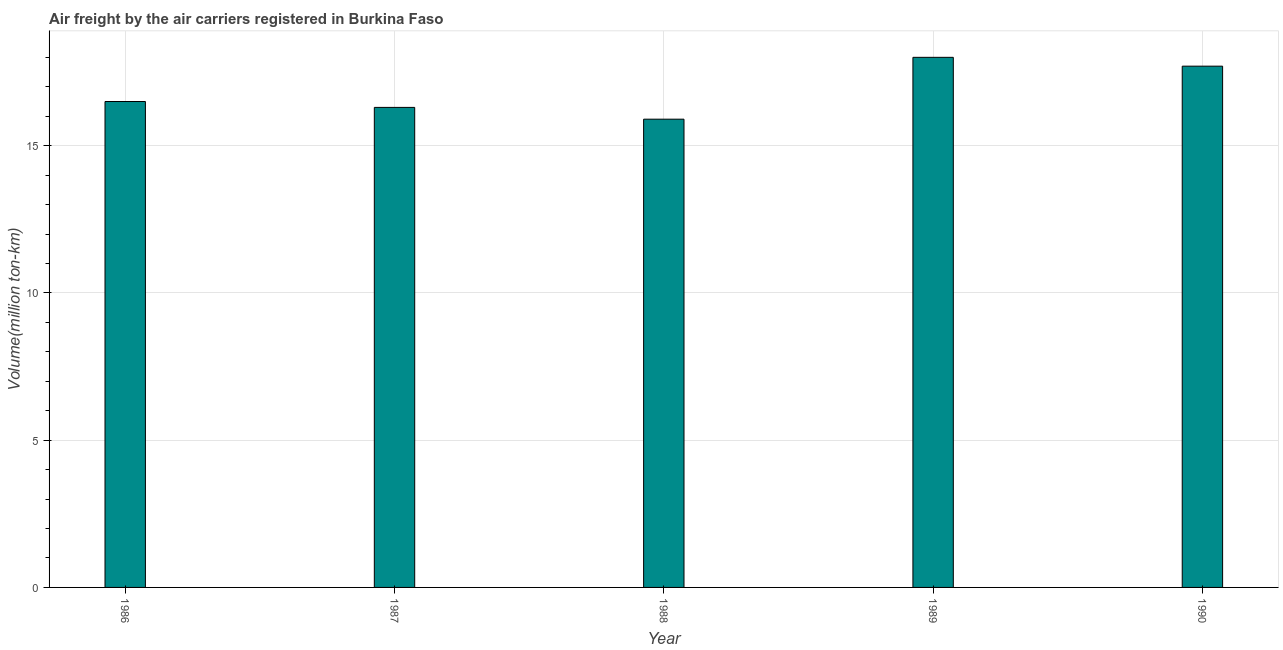Does the graph contain any zero values?
Your response must be concise. No. What is the title of the graph?
Keep it short and to the point. Air freight by the air carriers registered in Burkina Faso. What is the label or title of the Y-axis?
Offer a very short reply. Volume(million ton-km). What is the air freight in 1990?
Your response must be concise. 17.7. Across all years, what is the minimum air freight?
Your response must be concise. 15.9. In which year was the air freight minimum?
Your answer should be very brief. 1988. What is the sum of the air freight?
Provide a succinct answer. 84.4. What is the average air freight per year?
Ensure brevity in your answer.  16.88. Do a majority of the years between 1990 and 1989 (inclusive) have air freight greater than 2 million ton-km?
Your answer should be compact. No. What is the ratio of the air freight in 1987 to that in 1990?
Make the answer very short. 0.92. Is the air freight in 1986 less than that in 1987?
Provide a succinct answer. No. Is the difference between the air freight in 1987 and 1989 greater than the difference between any two years?
Offer a terse response. No. What is the difference between the highest and the second highest air freight?
Offer a very short reply. 0.3. What is the difference between the highest and the lowest air freight?
Provide a succinct answer. 2.1. Are all the bars in the graph horizontal?
Give a very brief answer. No. What is the difference between two consecutive major ticks on the Y-axis?
Your answer should be very brief. 5. Are the values on the major ticks of Y-axis written in scientific E-notation?
Your answer should be very brief. No. What is the Volume(million ton-km) in 1986?
Provide a short and direct response. 16.5. What is the Volume(million ton-km) in 1987?
Make the answer very short. 16.3. What is the Volume(million ton-km) in 1988?
Ensure brevity in your answer.  15.9. What is the Volume(million ton-km) of 1990?
Give a very brief answer. 17.7. What is the difference between the Volume(million ton-km) in 1986 and 1987?
Give a very brief answer. 0.2. What is the difference between the Volume(million ton-km) in 1986 and 1990?
Give a very brief answer. -1.2. What is the difference between the Volume(million ton-km) in 1987 and 1988?
Your answer should be very brief. 0.4. What is the difference between the Volume(million ton-km) in 1987 and 1989?
Provide a short and direct response. -1.7. What is the difference between the Volume(million ton-km) in 1988 and 1989?
Your answer should be very brief. -2.1. What is the ratio of the Volume(million ton-km) in 1986 to that in 1987?
Your response must be concise. 1.01. What is the ratio of the Volume(million ton-km) in 1986 to that in 1988?
Provide a succinct answer. 1.04. What is the ratio of the Volume(million ton-km) in 1986 to that in 1989?
Keep it short and to the point. 0.92. What is the ratio of the Volume(million ton-km) in 1986 to that in 1990?
Your answer should be very brief. 0.93. What is the ratio of the Volume(million ton-km) in 1987 to that in 1988?
Your response must be concise. 1.02. What is the ratio of the Volume(million ton-km) in 1987 to that in 1989?
Your response must be concise. 0.91. What is the ratio of the Volume(million ton-km) in 1987 to that in 1990?
Ensure brevity in your answer.  0.92. What is the ratio of the Volume(million ton-km) in 1988 to that in 1989?
Your answer should be very brief. 0.88. What is the ratio of the Volume(million ton-km) in 1988 to that in 1990?
Keep it short and to the point. 0.9. 